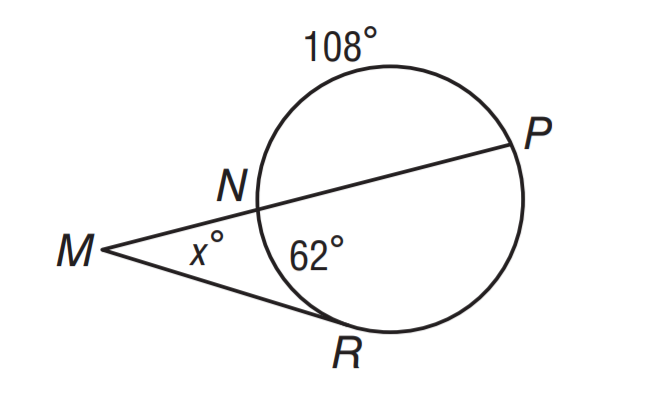What geometrical concepts can be observed in this image? This image exemplifies several geometrical concepts. Firstly, there are straight lines intersecting at a point, forming angles. There's also a circle, with a tangential line from point P touching the circle at point N, creating a tangent-secant angle. The relationship between the angles can lead us to insights about the properties of circles and lines, such as angle sums in polygons and the special angle measures formed by tangents and secants that intersect a circle. 